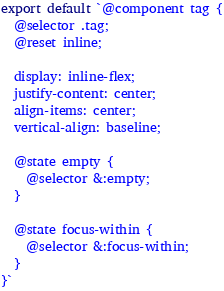<code> <loc_0><loc_0><loc_500><loc_500><_JavaScript_>export default `@component tag {
  @selector .tag;
  @reset inline;

  display: inline-flex;
  justify-content: center;
  align-items: center;
  vertical-align: baseline;

  @state empty {
    @selector &:empty;
  }

  @state focus-within {
    @selector &:focus-within;
  }
}`
</code> 